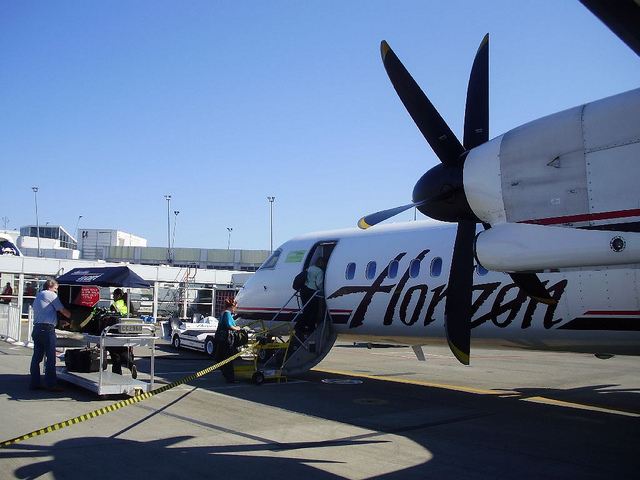Identify the text displayed in this image. florzon 